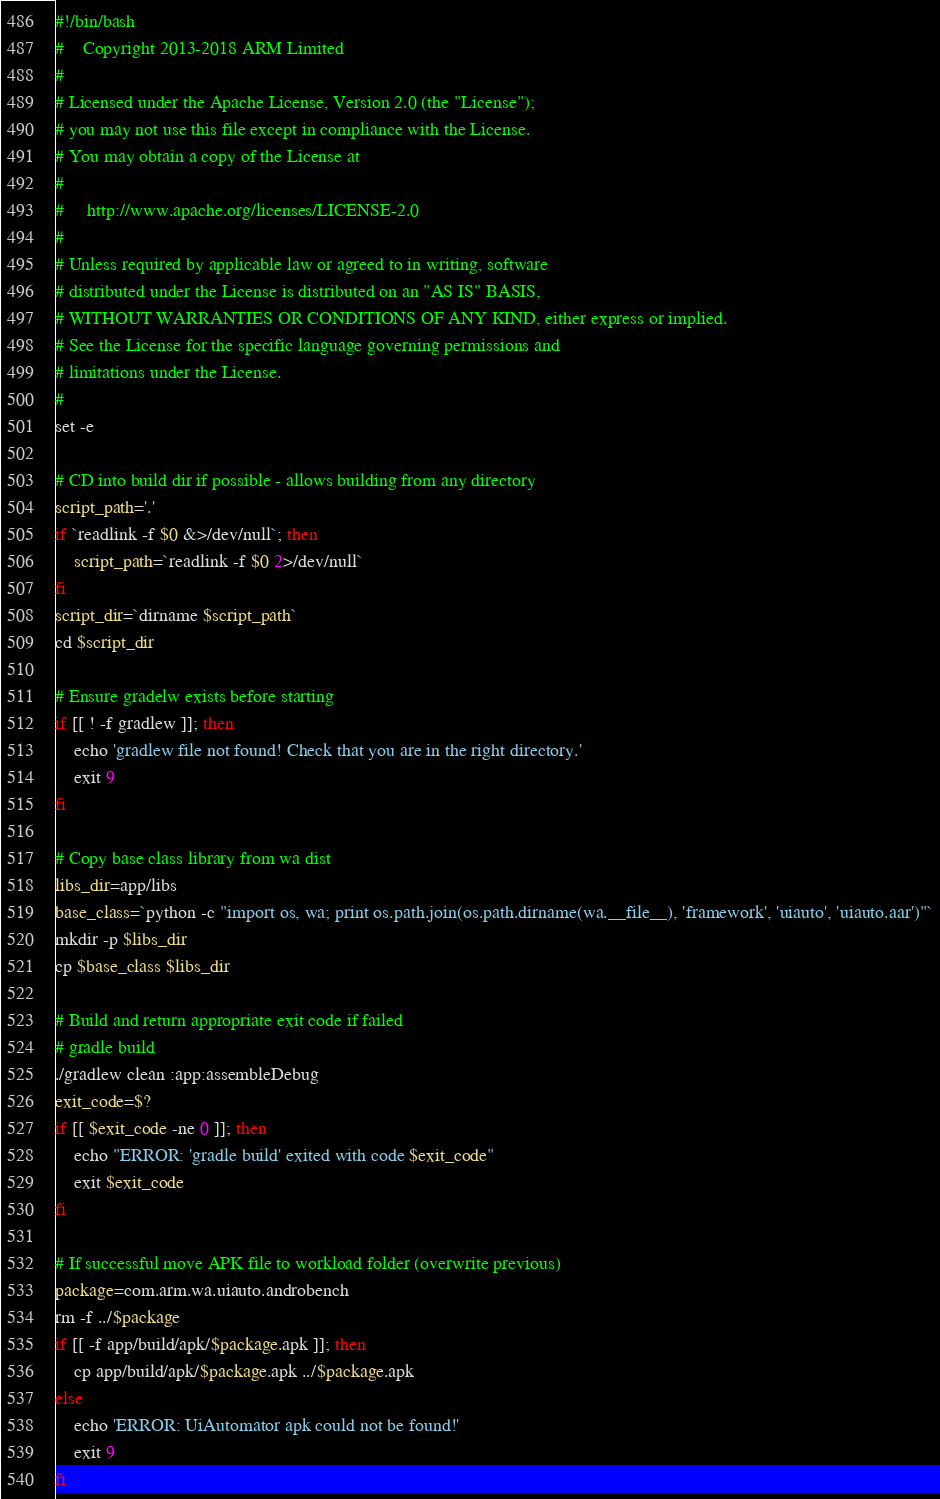<code> <loc_0><loc_0><loc_500><loc_500><_Bash_>#!/bin/bash
#    Copyright 2013-2018 ARM Limited
#
# Licensed under the Apache License, Version 2.0 (the "License");
# you may not use this file except in compliance with the License.
# You may obtain a copy of the License at
#
#     http://www.apache.org/licenses/LICENSE-2.0
#
# Unless required by applicable law or agreed to in writing, software
# distributed under the License is distributed on an "AS IS" BASIS,
# WITHOUT WARRANTIES OR CONDITIONS OF ANY KIND, either express or implied.
# See the License for the specific language governing permissions and
# limitations under the License.
#
set -e

# CD into build dir if possible - allows building from any directory
script_path='.'
if `readlink -f $0 &>/dev/null`; then
    script_path=`readlink -f $0 2>/dev/null`
fi
script_dir=`dirname $script_path`
cd $script_dir

# Ensure gradelw exists before starting
if [[ ! -f gradlew ]]; then
    echo 'gradlew file not found! Check that you are in the right directory.'
    exit 9
fi

# Copy base class library from wa dist
libs_dir=app/libs
base_class=`python -c "import os, wa; print os.path.join(os.path.dirname(wa.__file__), 'framework', 'uiauto', 'uiauto.aar')"`
mkdir -p $libs_dir
cp $base_class $libs_dir

# Build and return appropriate exit code if failed
# gradle build
./gradlew clean :app:assembleDebug
exit_code=$?
if [[ $exit_code -ne 0 ]]; then
    echo "ERROR: 'gradle build' exited with code $exit_code"
    exit $exit_code
fi

# If successful move APK file to workload folder (overwrite previous)
package=com.arm.wa.uiauto.androbench
rm -f ../$package
if [[ -f app/build/apk/$package.apk ]]; then
    cp app/build/apk/$package.apk ../$package.apk
else
    echo 'ERROR: UiAutomator apk could not be found!'
    exit 9
fi
</code> 